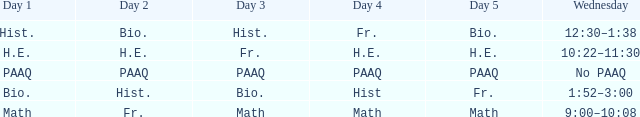What is the day 1 when day 5 is math? Math. Write the full table. {'header': ['Day 1', 'Day 2', 'Day 3', 'Day 4', 'Day 5', 'Wednesday'], 'rows': [['Hist.', 'Bio.', 'Hist.', 'Fr.', 'Bio.', '12:30–1:38'], ['H.E.', 'H.E.', 'Fr.', 'H.E.', 'H.E.', '10:22–11:30'], ['PAAQ', 'PAAQ', 'PAAQ', 'PAAQ', 'PAAQ', 'No PAAQ'], ['Bio.', 'Hist.', 'Bio.', 'Hist', 'Fr.', '1:52–3:00'], ['Math', 'Fr.', 'Math', 'Math', 'Math', '9:00–10:08']]} 